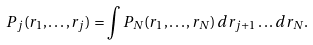Convert formula to latex. <formula><loc_0><loc_0><loc_500><loc_500>P _ { j } ( { r } _ { 1 } , \dots , { r } _ { j } ) = \int P _ { N } ( { r } _ { 1 } , \dots , { r } _ { N } ) \, d { r } _ { j + 1 } \dots d { r } _ { N } .</formula> 